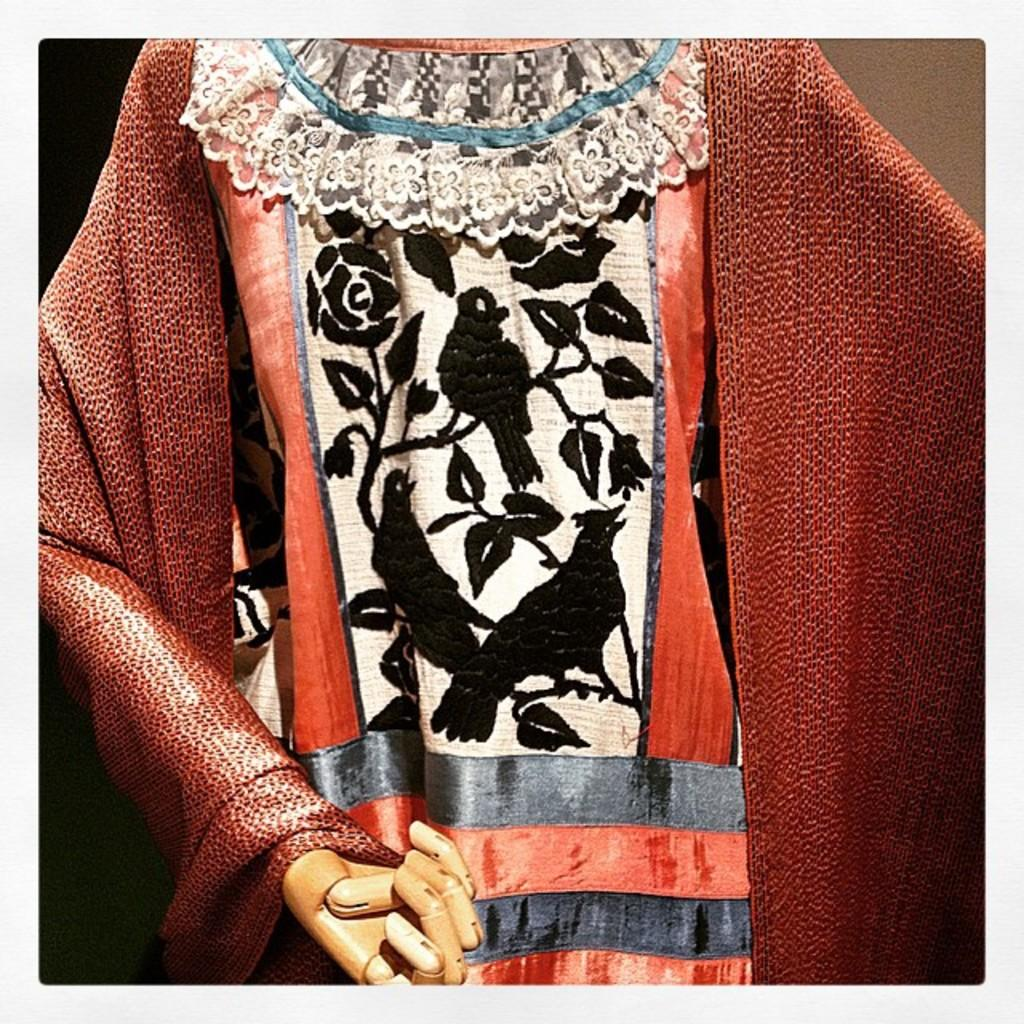What is displayed on the mannequin in the image? There are clothes on a mannequin in the image. Can you describe the clothes on the mannequin? The provided facts do not include a description of the clothes on the mannequin. What is the purpose of the mannequin in the image? The mannequin is likely used to display or showcase the clothes. Are there any cobwebs visible on the mannequin in the image? There is no mention of cobwebs in the provided facts, so it cannot be determined if any are present. 